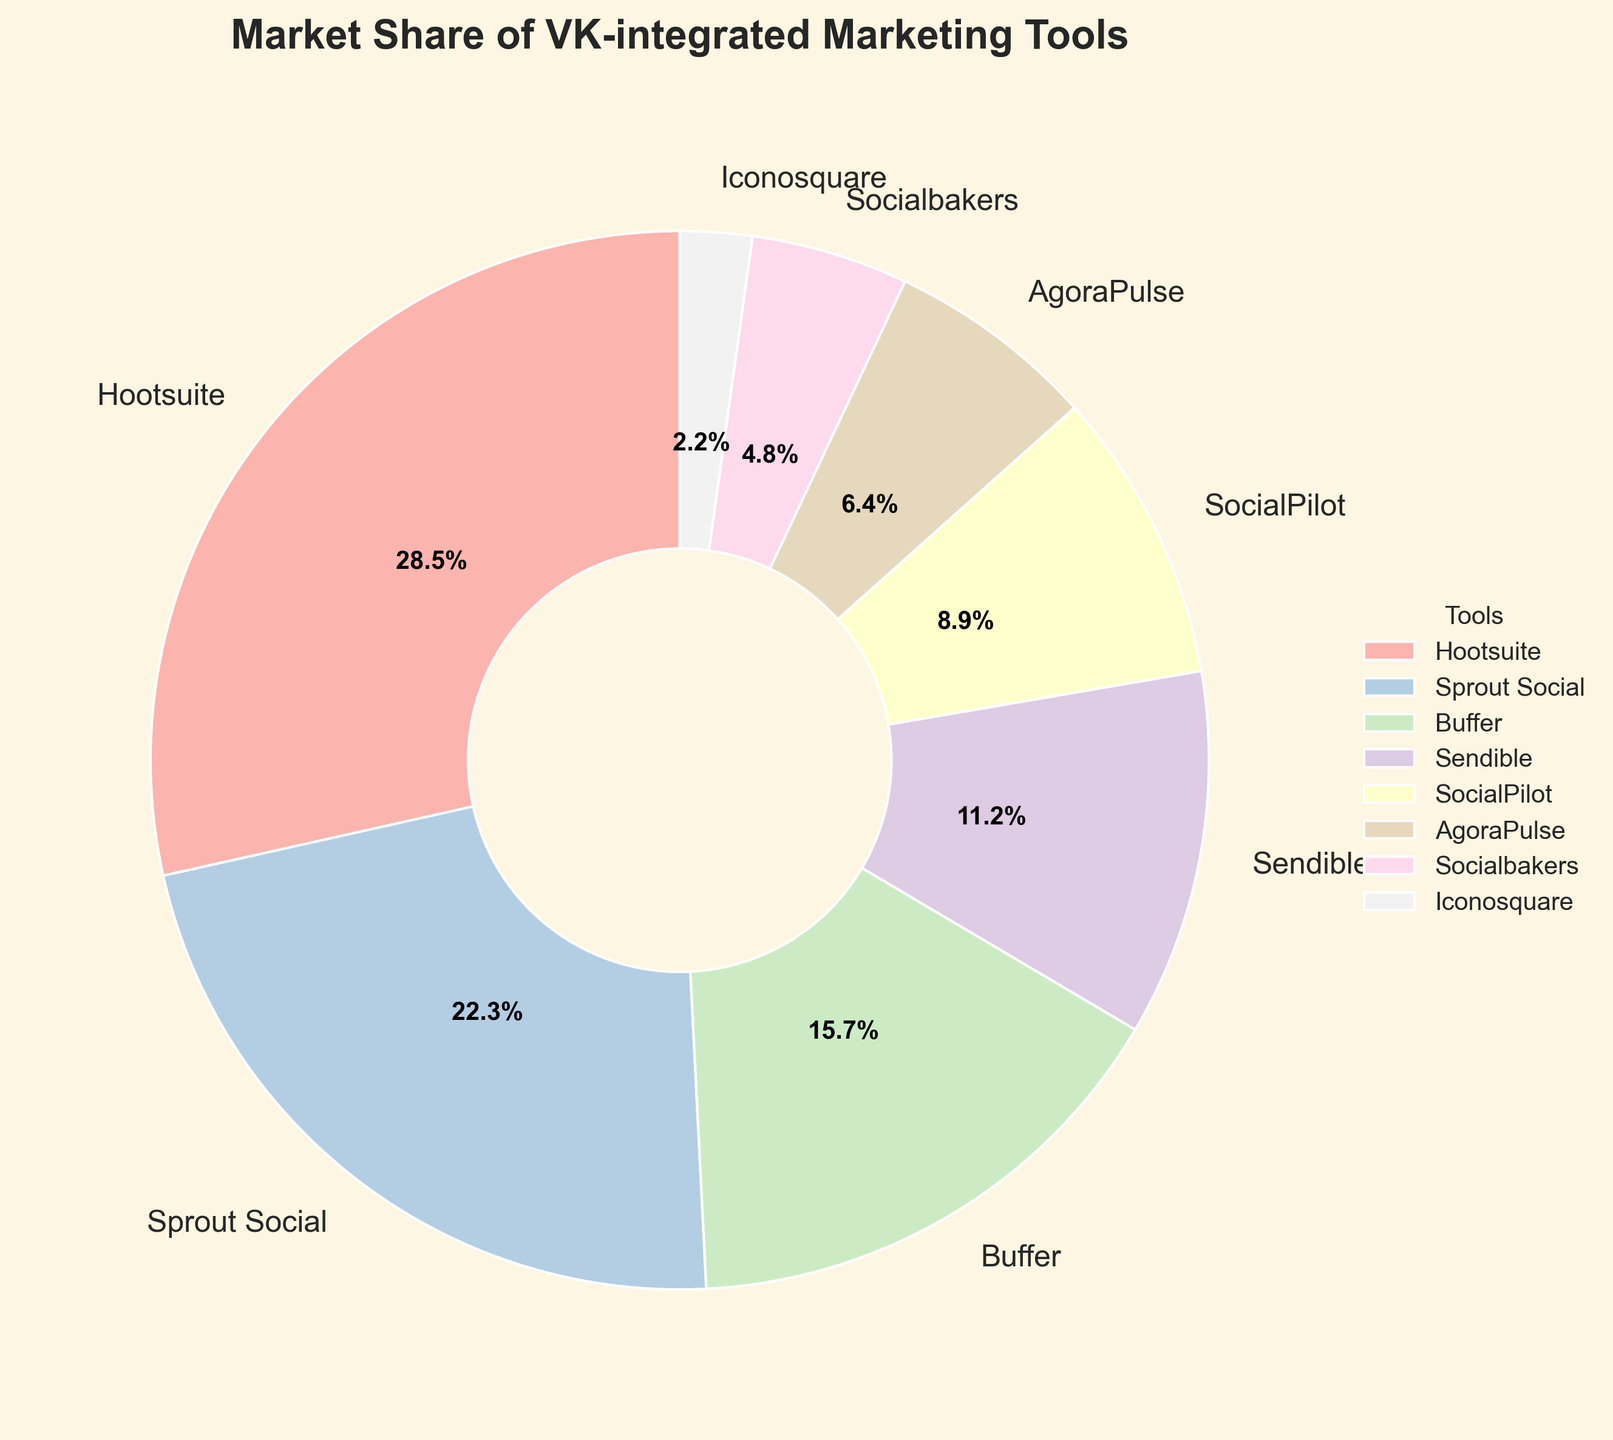What tool has the highest market share? By looking at the largest segment in the pie chart and checking which tool it corresponds to, we can determine the tool with the highest market share.
Answer: Hootsuite Which two tools have the closest market shares? Compare the sizes of the segments visually to find the two tools whose segments are nearly equal in size.
Answer: Sendible and SocialPilot What is the combined market share of SocialPilot and Buffer? Sum the percentages of SocialPilot (8.9%) and Buffer (15.7%) given in the pie chart. 8.9 + 15.7 = 24.6
Answer: 24.6% Which tool accounts for less than 5% of the market share? Look for segments that represent less than 5% of the pie chart and identify the corresponding tool.
Answer: Iconosquare How much larger is Hootsuite's market share compared to AgoraPulse? Subtract the market share of AgoraPulse (6.4%) from Hootsuite's market share (28.5%) using the visual information from the pie chart. 28.5 - 6.4 = 22.1
Answer: 22.1% What is the difference in market share between Sprout Social and Buffer? Subtract Buffer's market share (15.7%) from Sprout Social's market share (22.3%) based on the pie chart data. 22.3 - 15.7 = 6.6
Answer: 6.6% How many tools have a market share of over 10%? Count the segments in the pie chart that are greater than 10% each.
Answer: Four What is the average market share of Sendible, AgoraPulse, and Iconosquare? Sum the market shares of Sendible (11.2%), AgoraPulse (6.4%), and Iconosquare (2.2%) and then divide by 3. (11.2 + 6.4 + 2.2) / 3 = 6.6
Answer: 6.6% If the market share of Hootsuite and Sprout Social were combined, what percentage of the total market would they represent? Sum the market shares of Hootsuite (28.5%) and Sprout Social (22.3%). 28.5 + 22.3 = 50.8
Answer: 50.8% Which tool has a market share closest to 5%? Identify the segment closest to 5% by looking at the size of each segment and determining which tool it belongs to.
Answer: Socialbakers 